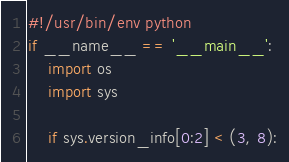Convert code to text. <code><loc_0><loc_0><loc_500><loc_500><_Python_>#!/usr/bin/env python
if __name__ == '__main__':
    import os
    import sys

    if sys.version_info[0:2] < (3, 8):</code> 